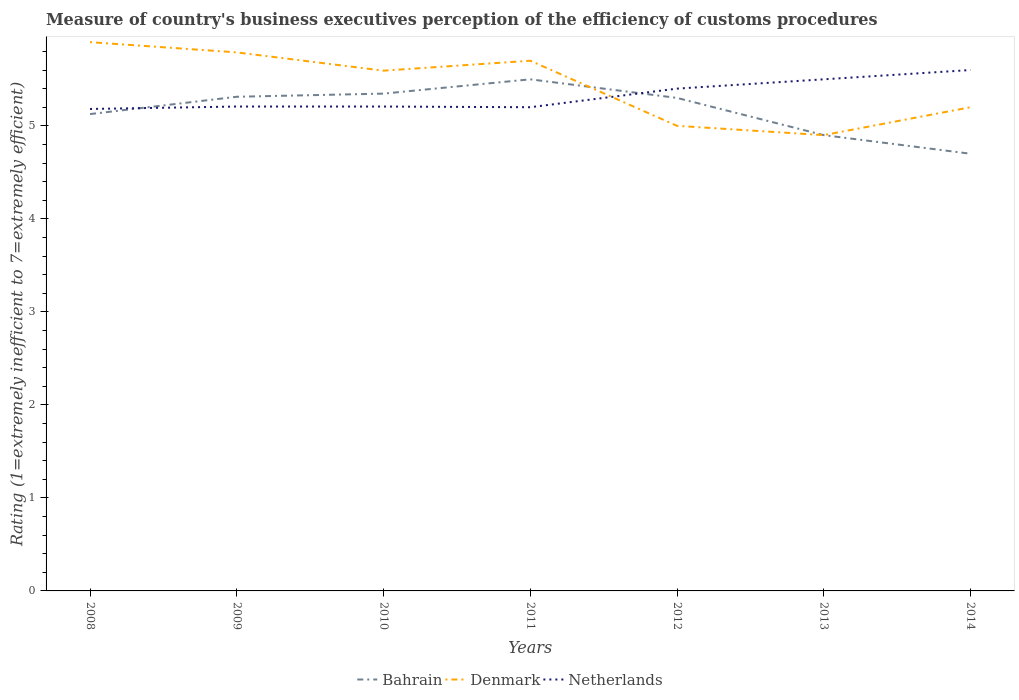How many different coloured lines are there?
Give a very brief answer. 3. Across all years, what is the maximum rating of the efficiency of customs procedure in Bahrain?
Offer a very short reply. 4.7. What is the total rating of the efficiency of customs procedure in Denmark in the graph?
Make the answer very short. 0.5. What is the difference between the highest and the second highest rating of the efficiency of customs procedure in Bahrain?
Keep it short and to the point. 0.8. What is the difference between the highest and the lowest rating of the efficiency of customs procedure in Denmark?
Your answer should be very brief. 4. Is the rating of the efficiency of customs procedure in Bahrain strictly greater than the rating of the efficiency of customs procedure in Netherlands over the years?
Your response must be concise. No. How many lines are there?
Provide a succinct answer. 3. How many years are there in the graph?
Provide a succinct answer. 7. What is the difference between two consecutive major ticks on the Y-axis?
Your answer should be very brief. 1. Does the graph contain any zero values?
Provide a short and direct response. No. Does the graph contain grids?
Make the answer very short. No. How many legend labels are there?
Offer a terse response. 3. What is the title of the graph?
Make the answer very short. Measure of country's business executives perception of the efficiency of customs procedures. Does "Hong Kong" appear as one of the legend labels in the graph?
Make the answer very short. No. What is the label or title of the Y-axis?
Keep it short and to the point. Rating (1=extremely inefficient to 7=extremely efficient). What is the Rating (1=extremely inefficient to 7=extremely efficient) of Bahrain in 2008?
Ensure brevity in your answer.  5.13. What is the Rating (1=extremely inefficient to 7=extremely efficient) in Denmark in 2008?
Make the answer very short. 5.9. What is the Rating (1=extremely inefficient to 7=extremely efficient) in Netherlands in 2008?
Offer a terse response. 5.18. What is the Rating (1=extremely inefficient to 7=extremely efficient) in Bahrain in 2009?
Offer a terse response. 5.31. What is the Rating (1=extremely inefficient to 7=extremely efficient) in Denmark in 2009?
Offer a very short reply. 5.79. What is the Rating (1=extremely inefficient to 7=extremely efficient) in Netherlands in 2009?
Provide a short and direct response. 5.21. What is the Rating (1=extremely inefficient to 7=extremely efficient) in Bahrain in 2010?
Offer a terse response. 5.35. What is the Rating (1=extremely inefficient to 7=extremely efficient) in Denmark in 2010?
Ensure brevity in your answer.  5.59. What is the Rating (1=extremely inefficient to 7=extremely efficient) of Netherlands in 2010?
Offer a very short reply. 5.21. What is the Rating (1=extremely inefficient to 7=extremely efficient) of Netherlands in 2011?
Give a very brief answer. 5.2. What is the Rating (1=extremely inefficient to 7=extremely efficient) of Denmark in 2012?
Provide a succinct answer. 5. What is the Rating (1=extremely inefficient to 7=extremely efficient) in Netherlands in 2012?
Offer a terse response. 5.4. What is the Rating (1=extremely inefficient to 7=extremely efficient) of Bahrain in 2013?
Make the answer very short. 4.9. What is the Rating (1=extremely inefficient to 7=extremely efficient) in Denmark in 2013?
Offer a terse response. 4.9. What is the Rating (1=extremely inefficient to 7=extremely efficient) in Denmark in 2014?
Your answer should be compact. 5.2. Across all years, what is the maximum Rating (1=extremely inefficient to 7=extremely efficient) of Denmark?
Your answer should be very brief. 5.9. Across all years, what is the minimum Rating (1=extremely inefficient to 7=extremely efficient) in Netherlands?
Ensure brevity in your answer.  5.18. What is the total Rating (1=extremely inefficient to 7=extremely efficient) of Bahrain in the graph?
Make the answer very short. 36.19. What is the total Rating (1=extremely inefficient to 7=extremely efficient) in Denmark in the graph?
Keep it short and to the point. 38.08. What is the total Rating (1=extremely inefficient to 7=extremely efficient) in Netherlands in the graph?
Ensure brevity in your answer.  37.3. What is the difference between the Rating (1=extremely inefficient to 7=extremely efficient) in Bahrain in 2008 and that in 2009?
Offer a very short reply. -0.19. What is the difference between the Rating (1=extremely inefficient to 7=extremely efficient) in Denmark in 2008 and that in 2009?
Ensure brevity in your answer.  0.11. What is the difference between the Rating (1=extremely inefficient to 7=extremely efficient) in Netherlands in 2008 and that in 2009?
Ensure brevity in your answer.  -0.03. What is the difference between the Rating (1=extremely inefficient to 7=extremely efficient) of Bahrain in 2008 and that in 2010?
Provide a succinct answer. -0.22. What is the difference between the Rating (1=extremely inefficient to 7=extremely efficient) in Denmark in 2008 and that in 2010?
Offer a very short reply. 0.31. What is the difference between the Rating (1=extremely inefficient to 7=extremely efficient) of Netherlands in 2008 and that in 2010?
Offer a very short reply. -0.03. What is the difference between the Rating (1=extremely inefficient to 7=extremely efficient) of Bahrain in 2008 and that in 2011?
Provide a short and direct response. -0.37. What is the difference between the Rating (1=extremely inefficient to 7=extremely efficient) in Denmark in 2008 and that in 2011?
Your response must be concise. 0.2. What is the difference between the Rating (1=extremely inefficient to 7=extremely efficient) of Netherlands in 2008 and that in 2011?
Keep it short and to the point. -0.02. What is the difference between the Rating (1=extremely inefficient to 7=extremely efficient) in Bahrain in 2008 and that in 2012?
Offer a very short reply. -0.17. What is the difference between the Rating (1=extremely inefficient to 7=extremely efficient) of Denmark in 2008 and that in 2012?
Your answer should be very brief. 0.9. What is the difference between the Rating (1=extremely inefficient to 7=extremely efficient) of Netherlands in 2008 and that in 2012?
Provide a succinct answer. -0.22. What is the difference between the Rating (1=extremely inefficient to 7=extremely efficient) of Bahrain in 2008 and that in 2013?
Your answer should be compact. 0.23. What is the difference between the Rating (1=extremely inefficient to 7=extremely efficient) of Denmark in 2008 and that in 2013?
Offer a terse response. 1. What is the difference between the Rating (1=extremely inefficient to 7=extremely efficient) of Netherlands in 2008 and that in 2013?
Offer a terse response. -0.32. What is the difference between the Rating (1=extremely inefficient to 7=extremely efficient) in Bahrain in 2008 and that in 2014?
Your answer should be very brief. 0.43. What is the difference between the Rating (1=extremely inefficient to 7=extremely efficient) of Denmark in 2008 and that in 2014?
Offer a terse response. 0.7. What is the difference between the Rating (1=extremely inefficient to 7=extremely efficient) in Netherlands in 2008 and that in 2014?
Offer a very short reply. -0.42. What is the difference between the Rating (1=extremely inefficient to 7=extremely efficient) in Bahrain in 2009 and that in 2010?
Make the answer very short. -0.03. What is the difference between the Rating (1=extremely inefficient to 7=extremely efficient) in Denmark in 2009 and that in 2010?
Your answer should be very brief. 0.2. What is the difference between the Rating (1=extremely inefficient to 7=extremely efficient) in Bahrain in 2009 and that in 2011?
Your response must be concise. -0.19. What is the difference between the Rating (1=extremely inefficient to 7=extremely efficient) of Denmark in 2009 and that in 2011?
Make the answer very short. 0.09. What is the difference between the Rating (1=extremely inefficient to 7=extremely efficient) of Netherlands in 2009 and that in 2011?
Your answer should be very brief. 0.01. What is the difference between the Rating (1=extremely inefficient to 7=extremely efficient) in Bahrain in 2009 and that in 2012?
Your answer should be very brief. 0.01. What is the difference between the Rating (1=extremely inefficient to 7=extremely efficient) of Denmark in 2009 and that in 2012?
Give a very brief answer. 0.79. What is the difference between the Rating (1=extremely inefficient to 7=extremely efficient) of Netherlands in 2009 and that in 2012?
Your answer should be compact. -0.19. What is the difference between the Rating (1=extremely inefficient to 7=extremely efficient) in Bahrain in 2009 and that in 2013?
Provide a succinct answer. 0.41. What is the difference between the Rating (1=extremely inefficient to 7=extremely efficient) of Denmark in 2009 and that in 2013?
Ensure brevity in your answer.  0.89. What is the difference between the Rating (1=extremely inefficient to 7=extremely efficient) in Netherlands in 2009 and that in 2013?
Your answer should be compact. -0.29. What is the difference between the Rating (1=extremely inefficient to 7=extremely efficient) in Bahrain in 2009 and that in 2014?
Your response must be concise. 0.61. What is the difference between the Rating (1=extremely inefficient to 7=extremely efficient) in Denmark in 2009 and that in 2014?
Keep it short and to the point. 0.59. What is the difference between the Rating (1=extremely inefficient to 7=extremely efficient) in Netherlands in 2009 and that in 2014?
Give a very brief answer. -0.39. What is the difference between the Rating (1=extremely inefficient to 7=extremely efficient) in Bahrain in 2010 and that in 2011?
Give a very brief answer. -0.15. What is the difference between the Rating (1=extremely inefficient to 7=extremely efficient) in Denmark in 2010 and that in 2011?
Offer a terse response. -0.11. What is the difference between the Rating (1=extremely inefficient to 7=extremely efficient) of Netherlands in 2010 and that in 2011?
Offer a very short reply. 0.01. What is the difference between the Rating (1=extremely inefficient to 7=extremely efficient) in Bahrain in 2010 and that in 2012?
Your answer should be compact. 0.05. What is the difference between the Rating (1=extremely inefficient to 7=extremely efficient) in Denmark in 2010 and that in 2012?
Ensure brevity in your answer.  0.59. What is the difference between the Rating (1=extremely inefficient to 7=extremely efficient) of Netherlands in 2010 and that in 2012?
Make the answer very short. -0.19. What is the difference between the Rating (1=extremely inefficient to 7=extremely efficient) of Bahrain in 2010 and that in 2013?
Make the answer very short. 0.45. What is the difference between the Rating (1=extremely inefficient to 7=extremely efficient) of Denmark in 2010 and that in 2013?
Offer a terse response. 0.69. What is the difference between the Rating (1=extremely inefficient to 7=extremely efficient) in Netherlands in 2010 and that in 2013?
Offer a very short reply. -0.29. What is the difference between the Rating (1=extremely inefficient to 7=extremely efficient) of Bahrain in 2010 and that in 2014?
Offer a very short reply. 0.65. What is the difference between the Rating (1=extremely inefficient to 7=extremely efficient) in Denmark in 2010 and that in 2014?
Provide a short and direct response. 0.39. What is the difference between the Rating (1=extremely inefficient to 7=extremely efficient) in Netherlands in 2010 and that in 2014?
Your answer should be very brief. -0.39. What is the difference between the Rating (1=extremely inefficient to 7=extremely efficient) in Bahrain in 2011 and that in 2012?
Offer a very short reply. 0.2. What is the difference between the Rating (1=extremely inefficient to 7=extremely efficient) of Denmark in 2011 and that in 2012?
Provide a short and direct response. 0.7. What is the difference between the Rating (1=extremely inefficient to 7=extremely efficient) in Denmark in 2011 and that in 2013?
Offer a terse response. 0.8. What is the difference between the Rating (1=extremely inefficient to 7=extremely efficient) in Netherlands in 2011 and that in 2013?
Your answer should be very brief. -0.3. What is the difference between the Rating (1=extremely inefficient to 7=extremely efficient) in Netherlands in 2011 and that in 2014?
Offer a very short reply. -0.4. What is the difference between the Rating (1=extremely inefficient to 7=extremely efficient) in Denmark in 2012 and that in 2013?
Your answer should be compact. 0.1. What is the difference between the Rating (1=extremely inefficient to 7=extremely efficient) of Netherlands in 2012 and that in 2013?
Ensure brevity in your answer.  -0.1. What is the difference between the Rating (1=extremely inefficient to 7=extremely efficient) of Bahrain in 2012 and that in 2014?
Offer a very short reply. 0.6. What is the difference between the Rating (1=extremely inefficient to 7=extremely efficient) of Bahrain in 2008 and the Rating (1=extremely inefficient to 7=extremely efficient) of Denmark in 2009?
Offer a terse response. -0.66. What is the difference between the Rating (1=extremely inefficient to 7=extremely efficient) in Bahrain in 2008 and the Rating (1=extremely inefficient to 7=extremely efficient) in Netherlands in 2009?
Make the answer very short. -0.08. What is the difference between the Rating (1=extremely inefficient to 7=extremely efficient) of Denmark in 2008 and the Rating (1=extremely inefficient to 7=extremely efficient) of Netherlands in 2009?
Provide a short and direct response. 0.69. What is the difference between the Rating (1=extremely inefficient to 7=extremely efficient) of Bahrain in 2008 and the Rating (1=extremely inefficient to 7=extremely efficient) of Denmark in 2010?
Ensure brevity in your answer.  -0.47. What is the difference between the Rating (1=extremely inefficient to 7=extremely efficient) of Bahrain in 2008 and the Rating (1=extremely inefficient to 7=extremely efficient) of Netherlands in 2010?
Provide a short and direct response. -0.08. What is the difference between the Rating (1=extremely inefficient to 7=extremely efficient) in Denmark in 2008 and the Rating (1=extremely inefficient to 7=extremely efficient) in Netherlands in 2010?
Offer a very short reply. 0.69. What is the difference between the Rating (1=extremely inefficient to 7=extremely efficient) of Bahrain in 2008 and the Rating (1=extremely inefficient to 7=extremely efficient) of Denmark in 2011?
Provide a succinct answer. -0.57. What is the difference between the Rating (1=extremely inefficient to 7=extremely efficient) of Bahrain in 2008 and the Rating (1=extremely inefficient to 7=extremely efficient) of Netherlands in 2011?
Provide a succinct answer. -0.07. What is the difference between the Rating (1=extremely inefficient to 7=extremely efficient) in Denmark in 2008 and the Rating (1=extremely inefficient to 7=extremely efficient) in Netherlands in 2011?
Offer a terse response. 0.7. What is the difference between the Rating (1=extremely inefficient to 7=extremely efficient) of Bahrain in 2008 and the Rating (1=extremely inefficient to 7=extremely efficient) of Denmark in 2012?
Keep it short and to the point. 0.13. What is the difference between the Rating (1=extremely inefficient to 7=extremely efficient) in Bahrain in 2008 and the Rating (1=extremely inefficient to 7=extremely efficient) in Netherlands in 2012?
Make the answer very short. -0.27. What is the difference between the Rating (1=extremely inefficient to 7=extremely efficient) in Denmark in 2008 and the Rating (1=extremely inefficient to 7=extremely efficient) in Netherlands in 2012?
Give a very brief answer. 0.5. What is the difference between the Rating (1=extremely inefficient to 7=extremely efficient) of Bahrain in 2008 and the Rating (1=extremely inefficient to 7=extremely efficient) of Denmark in 2013?
Your response must be concise. 0.23. What is the difference between the Rating (1=extremely inefficient to 7=extremely efficient) of Bahrain in 2008 and the Rating (1=extremely inefficient to 7=extremely efficient) of Netherlands in 2013?
Offer a terse response. -0.37. What is the difference between the Rating (1=extremely inefficient to 7=extremely efficient) of Denmark in 2008 and the Rating (1=extremely inefficient to 7=extremely efficient) of Netherlands in 2013?
Your answer should be very brief. 0.4. What is the difference between the Rating (1=extremely inefficient to 7=extremely efficient) of Bahrain in 2008 and the Rating (1=extremely inefficient to 7=extremely efficient) of Denmark in 2014?
Provide a short and direct response. -0.07. What is the difference between the Rating (1=extremely inefficient to 7=extremely efficient) of Bahrain in 2008 and the Rating (1=extremely inefficient to 7=extremely efficient) of Netherlands in 2014?
Provide a short and direct response. -0.47. What is the difference between the Rating (1=extremely inefficient to 7=extremely efficient) of Denmark in 2008 and the Rating (1=extremely inefficient to 7=extremely efficient) of Netherlands in 2014?
Your answer should be very brief. 0.3. What is the difference between the Rating (1=extremely inefficient to 7=extremely efficient) of Bahrain in 2009 and the Rating (1=extremely inefficient to 7=extremely efficient) of Denmark in 2010?
Provide a succinct answer. -0.28. What is the difference between the Rating (1=extremely inefficient to 7=extremely efficient) in Bahrain in 2009 and the Rating (1=extremely inefficient to 7=extremely efficient) in Netherlands in 2010?
Keep it short and to the point. 0.11. What is the difference between the Rating (1=extremely inefficient to 7=extremely efficient) in Denmark in 2009 and the Rating (1=extremely inefficient to 7=extremely efficient) in Netherlands in 2010?
Your answer should be compact. 0.58. What is the difference between the Rating (1=extremely inefficient to 7=extremely efficient) of Bahrain in 2009 and the Rating (1=extremely inefficient to 7=extremely efficient) of Denmark in 2011?
Offer a terse response. -0.39. What is the difference between the Rating (1=extremely inefficient to 7=extremely efficient) of Bahrain in 2009 and the Rating (1=extremely inefficient to 7=extremely efficient) of Netherlands in 2011?
Your answer should be compact. 0.11. What is the difference between the Rating (1=extremely inefficient to 7=extremely efficient) in Denmark in 2009 and the Rating (1=extremely inefficient to 7=extremely efficient) in Netherlands in 2011?
Provide a short and direct response. 0.59. What is the difference between the Rating (1=extremely inefficient to 7=extremely efficient) in Bahrain in 2009 and the Rating (1=extremely inefficient to 7=extremely efficient) in Denmark in 2012?
Make the answer very short. 0.31. What is the difference between the Rating (1=extremely inefficient to 7=extremely efficient) in Bahrain in 2009 and the Rating (1=extremely inefficient to 7=extremely efficient) in Netherlands in 2012?
Offer a very short reply. -0.09. What is the difference between the Rating (1=extremely inefficient to 7=extremely efficient) of Denmark in 2009 and the Rating (1=extremely inefficient to 7=extremely efficient) of Netherlands in 2012?
Your answer should be very brief. 0.39. What is the difference between the Rating (1=extremely inefficient to 7=extremely efficient) in Bahrain in 2009 and the Rating (1=extremely inefficient to 7=extremely efficient) in Denmark in 2013?
Your answer should be compact. 0.41. What is the difference between the Rating (1=extremely inefficient to 7=extremely efficient) of Bahrain in 2009 and the Rating (1=extremely inefficient to 7=extremely efficient) of Netherlands in 2013?
Keep it short and to the point. -0.19. What is the difference between the Rating (1=extremely inefficient to 7=extremely efficient) of Denmark in 2009 and the Rating (1=extremely inefficient to 7=extremely efficient) of Netherlands in 2013?
Offer a terse response. 0.29. What is the difference between the Rating (1=extremely inefficient to 7=extremely efficient) of Bahrain in 2009 and the Rating (1=extremely inefficient to 7=extremely efficient) of Denmark in 2014?
Provide a short and direct response. 0.11. What is the difference between the Rating (1=extremely inefficient to 7=extremely efficient) of Bahrain in 2009 and the Rating (1=extremely inefficient to 7=extremely efficient) of Netherlands in 2014?
Your response must be concise. -0.29. What is the difference between the Rating (1=extremely inefficient to 7=extremely efficient) in Denmark in 2009 and the Rating (1=extremely inefficient to 7=extremely efficient) in Netherlands in 2014?
Make the answer very short. 0.19. What is the difference between the Rating (1=extremely inefficient to 7=extremely efficient) of Bahrain in 2010 and the Rating (1=extremely inefficient to 7=extremely efficient) of Denmark in 2011?
Give a very brief answer. -0.35. What is the difference between the Rating (1=extremely inefficient to 7=extremely efficient) in Bahrain in 2010 and the Rating (1=extremely inefficient to 7=extremely efficient) in Netherlands in 2011?
Your response must be concise. 0.15. What is the difference between the Rating (1=extremely inefficient to 7=extremely efficient) of Denmark in 2010 and the Rating (1=extremely inefficient to 7=extremely efficient) of Netherlands in 2011?
Give a very brief answer. 0.39. What is the difference between the Rating (1=extremely inefficient to 7=extremely efficient) of Bahrain in 2010 and the Rating (1=extremely inefficient to 7=extremely efficient) of Denmark in 2012?
Ensure brevity in your answer.  0.35. What is the difference between the Rating (1=extremely inefficient to 7=extremely efficient) of Bahrain in 2010 and the Rating (1=extremely inefficient to 7=extremely efficient) of Netherlands in 2012?
Your response must be concise. -0.05. What is the difference between the Rating (1=extremely inefficient to 7=extremely efficient) in Denmark in 2010 and the Rating (1=extremely inefficient to 7=extremely efficient) in Netherlands in 2012?
Provide a succinct answer. 0.19. What is the difference between the Rating (1=extremely inefficient to 7=extremely efficient) of Bahrain in 2010 and the Rating (1=extremely inefficient to 7=extremely efficient) of Denmark in 2013?
Your answer should be very brief. 0.45. What is the difference between the Rating (1=extremely inefficient to 7=extremely efficient) in Bahrain in 2010 and the Rating (1=extremely inefficient to 7=extremely efficient) in Netherlands in 2013?
Offer a very short reply. -0.15. What is the difference between the Rating (1=extremely inefficient to 7=extremely efficient) of Denmark in 2010 and the Rating (1=extremely inefficient to 7=extremely efficient) of Netherlands in 2013?
Keep it short and to the point. 0.09. What is the difference between the Rating (1=extremely inefficient to 7=extremely efficient) in Bahrain in 2010 and the Rating (1=extremely inefficient to 7=extremely efficient) in Denmark in 2014?
Your response must be concise. 0.15. What is the difference between the Rating (1=extremely inefficient to 7=extremely efficient) of Bahrain in 2010 and the Rating (1=extremely inefficient to 7=extremely efficient) of Netherlands in 2014?
Provide a succinct answer. -0.25. What is the difference between the Rating (1=extremely inefficient to 7=extremely efficient) of Denmark in 2010 and the Rating (1=extremely inefficient to 7=extremely efficient) of Netherlands in 2014?
Your response must be concise. -0.01. What is the difference between the Rating (1=extremely inefficient to 7=extremely efficient) in Denmark in 2011 and the Rating (1=extremely inefficient to 7=extremely efficient) in Netherlands in 2012?
Offer a terse response. 0.3. What is the difference between the Rating (1=extremely inefficient to 7=extremely efficient) of Bahrain in 2011 and the Rating (1=extremely inefficient to 7=extremely efficient) of Denmark in 2013?
Make the answer very short. 0.6. What is the difference between the Rating (1=extremely inefficient to 7=extremely efficient) in Bahrain in 2011 and the Rating (1=extremely inefficient to 7=extremely efficient) in Denmark in 2014?
Ensure brevity in your answer.  0.3. What is the difference between the Rating (1=extremely inefficient to 7=extremely efficient) in Denmark in 2011 and the Rating (1=extremely inefficient to 7=extremely efficient) in Netherlands in 2014?
Your answer should be compact. 0.1. What is the difference between the Rating (1=extremely inefficient to 7=extremely efficient) in Denmark in 2012 and the Rating (1=extremely inefficient to 7=extremely efficient) in Netherlands in 2013?
Provide a succinct answer. -0.5. What is the difference between the Rating (1=extremely inefficient to 7=extremely efficient) in Bahrain in 2012 and the Rating (1=extremely inefficient to 7=extremely efficient) in Netherlands in 2014?
Provide a short and direct response. -0.3. What is the difference between the Rating (1=extremely inefficient to 7=extremely efficient) in Bahrain in 2013 and the Rating (1=extremely inefficient to 7=extremely efficient) in Denmark in 2014?
Provide a short and direct response. -0.3. What is the difference between the Rating (1=extremely inefficient to 7=extremely efficient) in Denmark in 2013 and the Rating (1=extremely inefficient to 7=extremely efficient) in Netherlands in 2014?
Provide a short and direct response. -0.7. What is the average Rating (1=extremely inefficient to 7=extremely efficient) of Bahrain per year?
Keep it short and to the point. 5.17. What is the average Rating (1=extremely inefficient to 7=extremely efficient) of Denmark per year?
Give a very brief answer. 5.44. What is the average Rating (1=extremely inefficient to 7=extremely efficient) in Netherlands per year?
Your answer should be very brief. 5.33. In the year 2008, what is the difference between the Rating (1=extremely inefficient to 7=extremely efficient) in Bahrain and Rating (1=extremely inefficient to 7=extremely efficient) in Denmark?
Ensure brevity in your answer.  -0.77. In the year 2008, what is the difference between the Rating (1=extremely inefficient to 7=extremely efficient) of Bahrain and Rating (1=extremely inefficient to 7=extremely efficient) of Netherlands?
Provide a short and direct response. -0.06. In the year 2008, what is the difference between the Rating (1=extremely inefficient to 7=extremely efficient) of Denmark and Rating (1=extremely inefficient to 7=extremely efficient) of Netherlands?
Keep it short and to the point. 0.72. In the year 2009, what is the difference between the Rating (1=extremely inefficient to 7=extremely efficient) of Bahrain and Rating (1=extremely inefficient to 7=extremely efficient) of Denmark?
Provide a succinct answer. -0.48. In the year 2009, what is the difference between the Rating (1=extremely inefficient to 7=extremely efficient) in Bahrain and Rating (1=extremely inefficient to 7=extremely efficient) in Netherlands?
Your response must be concise. 0.1. In the year 2009, what is the difference between the Rating (1=extremely inefficient to 7=extremely efficient) of Denmark and Rating (1=extremely inefficient to 7=extremely efficient) of Netherlands?
Your answer should be very brief. 0.58. In the year 2010, what is the difference between the Rating (1=extremely inefficient to 7=extremely efficient) in Bahrain and Rating (1=extremely inefficient to 7=extremely efficient) in Denmark?
Offer a terse response. -0.25. In the year 2010, what is the difference between the Rating (1=extremely inefficient to 7=extremely efficient) of Bahrain and Rating (1=extremely inefficient to 7=extremely efficient) of Netherlands?
Keep it short and to the point. 0.14. In the year 2010, what is the difference between the Rating (1=extremely inefficient to 7=extremely efficient) in Denmark and Rating (1=extremely inefficient to 7=extremely efficient) in Netherlands?
Ensure brevity in your answer.  0.39. In the year 2011, what is the difference between the Rating (1=extremely inefficient to 7=extremely efficient) in Bahrain and Rating (1=extremely inefficient to 7=extremely efficient) in Denmark?
Provide a succinct answer. -0.2. In the year 2013, what is the difference between the Rating (1=extremely inefficient to 7=extremely efficient) in Bahrain and Rating (1=extremely inefficient to 7=extremely efficient) in Netherlands?
Offer a very short reply. -0.6. In the year 2014, what is the difference between the Rating (1=extremely inefficient to 7=extremely efficient) in Bahrain and Rating (1=extremely inefficient to 7=extremely efficient) in Denmark?
Your answer should be compact. -0.5. What is the ratio of the Rating (1=extremely inefficient to 7=extremely efficient) in Bahrain in 2008 to that in 2010?
Your answer should be very brief. 0.96. What is the ratio of the Rating (1=extremely inefficient to 7=extremely efficient) of Denmark in 2008 to that in 2010?
Your response must be concise. 1.05. What is the ratio of the Rating (1=extremely inefficient to 7=extremely efficient) of Netherlands in 2008 to that in 2010?
Make the answer very short. 0.99. What is the ratio of the Rating (1=extremely inefficient to 7=extremely efficient) in Bahrain in 2008 to that in 2011?
Your answer should be very brief. 0.93. What is the ratio of the Rating (1=extremely inefficient to 7=extremely efficient) of Denmark in 2008 to that in 2011?
Your answer should be very brief. 1.03. What is the ratio of the Rating (1=extremely inefficient to 7=extremely efficient) of Netherlands in 2008 to that in 2011?
Provide a succinct answer. 1. What is the ratio of the Rating (1=extremely inefficient to 7=extremely efficient) of Bahrain in 2008 to that in 2012?
Provide a short and direct response. 0.97. What is the ratio of the Rating (1=extremely inefficient to 7=extremely efficient) of Denmark in 2008 to that in 2012?
Keep it short and to the point. 1.18. What is the ratio of the Rating (1=extremely inefficient to 7=extremely efficient) of Netherlands in 2008 to that in 2012?
Your answer should be compact. 0.96. What is the ratio of the Rating (1=extremely inefficient to 7=extremely efficient) of Bahrain in 2008 to that in 2013?
Provide a short and direct response. 1.05. What is the ratio of the Rating (1=extremely inefficient to 7=extremely efficient) in Denmark in 2008 to that in 2013?
Offer a very short reply. 1.2. What is the ratio of the Rating (1=extremely inefficient to 7=extremely efficient) in Netherlands in 2008 to that in 2013?
Ensure brevity in your answer.  0.94. What is the ratio of the Rating (1=extremely inefficient to 7=extremely efficient) of Bahrain in 2008 to that in 2014?
Your response must be concise. 1.09. What is the ratio of the Rating (1=extremely inefficient to 7=extremely efficient) in Denmark in 2008 to that in 2014?
Keep it short and to the point. 1.13. What is the ratio of the Rating (1=extremely inefficient to 7=extremely efficient) in Netherlands in 2008 to that in 2014?
Provide a short and direct response. 0.93. What is the ratio of the Rating (1=extremely inefficient to 7=extremely efficient) in Denmark in 2009 to that in 2010?
Give a very brief answer. 1.04. What is the ratio of the Rating (1=extremely inefficient to 7=extremely efficient) of Netherlands in 2009 to that in 2010?
Provide a short and direct response. 1. What is the ratio of the Rating (1=extremely inefficient to 7=extremely efficient) in Bahrain in 2009 to that in 2011?
Keep it short and to the point. 0.97. What is the ratio of the Rating (1=extremely inefficient to 7=extremely efficient) in Denmark in 2009 to that in 2011?
Offer a terse response. 1.02. What is the ratio of the Rating (1=extremely inefficient to 7=extremely efficient) in Netherlands in 2009 to that in 2011?
Provide a succinct answer. 1. What is the ratio of the Rating (1=extremely inefficient to 7=extremely efficient) in Denmark in 2009 to that in 2012?
Give a very brief answer. 1.16. What is the ratio of the Rating (1=extremely inefficient to 7=extremely efficient) in Netherlands in 2009 to that in 2012?
Your response must be concise. 0.96. What is the ratio of the Rating (1=extremely inefficient to 7=extremely efficient) in Bahrain in 2009 to that in 2013?
Your answer should be compact. 1.08. What is the ratio of the Rating (1=extremely inefficient to 7=extremely efficient) of Denmark in 2009 to that in 2013?
Provide a succinct answer. 1.18. What is the ratio of the Rating (1=extremely inefficient to 7=extremely efficient) of Netherlands in 2009 to that in 2013?
Offer a terse response. 0.95. What is the ratio of the Rating (1=extremely inefficient to 7=extremely efficient) in Bahrain in 2009 to that in 2014?
Your response must be concise. 1.13. What is the ratio of the Rating (1=extremely inefficient to 7=extremely efficient) in Denmark in 2009 to that in 2014?
Provide a short and direct response. 1.11. What is the ratio of the Rating (1=extremely inefficient to 7=extremely efficient) of Netherlands in 2009 to that in 2014?
Ensure brevity in your answer.  0.93. What is the ratio of the Rating (1=extremely inefficient to 7=extremely efficient) in Bahrain in 2010 to that in 2011?
Your response must be concise. 0.97. What is the ratio of the Rating (1=extremely inefficient to 7=extremely efficient) in Denmark in 2010 to that in 2011?
Ensure brevity in your answer.  0.98. What is the ratio of the Rating (1=extremely inefficient to 7=extremely efficient) in Netherlands in 2010 to that in 2011?
Make the answer very short. 1. What is the ratio of the Rating (1=extremely inefficient to 7=extremely efficient) of Bahrain in 2010 to that in 2012?
Give a very brief answer. 1.01. What is the ratio of the Rating (1=extremely inefficient to 7=extremely efficient) of Denmark in 2010 to that in 2012?
Offer a terse response. 1.12. What is the ratio of the Rating (1=extremely inefficient to 7=extremely efficient) of Bahrain in 2010 to that in 2013?
Keep it short and to the point. 1.09. What is the ratio of the Rating (1=extremely inefficient to 7=extremely efficient) in Denmark in 2010 to that in 2013?
Provide a short and direct response. 1.14. What is the ratio of the Rating (1=extremely inefficient to 7=extremely efficient) in Netherlands in 2010 to that in 2013?
Your answer should be very brief. 0.95. What is the ratio of the Rating (1=extremely inefficient to 7=extremely efficient) in Bahrain in 2010 to that in 2014?
Your answer should be compact. 1.14. What is the ratio of the Rating (1=extremely inefficient to 7=extremely efficient) of Denmark in 2010 to that in 2014?
Your response must be concise. 1.08. What is the ratio of the Rating (1=extremely inefficient to 7=extremely efficient) of Netherlands in 2010 to that in 2014?
Offer a very short reply. 0.93. What is the ratio of the Rating (1=extremely inefficient to 7=extremely efficient) of Bahrain in 2011 to that in 2012?
Provide a succinct answer. 1.04. What is the ratio of the Rating (1=extremely inefficient to 7=extremely efficient) of Denmark in 2011 to that in 2012?
Offer a terse response. 1.14. What is the ratio of the Rating (1=extremely inefficient to 7=extremely efficient) of Netherlands in 2011 to that in 2012?
Make the answer very short. 0.96. What is the ratio of the Rating (1=extremely inefficient to 7=extremely efficient) of Bahrain in 2011 to that in 2013?
Ensure brevity in your answer.  1.12. What is the ratio of the Rating (1=extremely inefficient to 7=extremely efficient) of Denmark in 2011 to that in 2013?
Your answer should be very brief. 1.16. What is the ratio of the Rating (1=extremely inefficient to 7=extremely efficient) in Netherlands in 2011 to that in 2013?
Give a very brief answer. 0.95. What is the ratio of the Rating (1=extremely inefficient to 7=extremely efficient) in Bahrain in 2011 to that in 2014?
Make the answer very short. 1.17. What is the ratio of the Rating (1=extremely inefficient to 7=extremely efficient) of Denmark in 2011 to that in 2014?
Offer a very short reply. 1.1. What is the ratio of the Rating (1=extremely inefficient to 7=extremely efficient) in Netherlands in 2011 to that in 2014?
Give a very brief answer. 0.93. What is the ratio of the Rating (1=extremely inefficient to 7=extremely efficient) of Bahrain in 2012 to that in 2013?
Provide a short and direct response. 1.08. What is the ratio of the Rating (1=extremely inefficient to 7=extremely efficient) of Denmark in 2012 to that in 2013?
Provide a succinct answer. 1.02. What is the ratio of the Rating (1=extremely inefficient to 7=extremely efficient) of Netherlands in 2012 to that in 2013?
Provide a succinct answer. 0.98. What is the ratio of the Rating (1=extremely inefficient to 7=extremely efficient) in Bahrain in 2012 to that in 2014?
Your response must be concise. 1.13. What is the ratio of the Rating (1=extremely inefficient to 7=extremely efficient) in Denmark in 2012 to that in 2014?
Offer a very short reply. 0.96. What is the ratio of the Rating (1=extremely inefficient to 7=extremely efficient) in Netherlands in 2012 to that in 2014?
Make the answer very short. 0.96. What is the ratio of the Rating (1=extremely inefficient to 7=extremely efficient) in Bahrain in 2013 to that in 2014?
Provide a short and direct response. 1.04. What is the ratio of the Rating (1=extremely inefficient to 7=extremely efficient) in Denmark in 2013 to that in 2014?
Provide a short and direct response. 0.94. What is the ratio of the Rating (1=extremely inefficient to 7=extremely efficient) of Netherlands in 2013 to that in 2014?
Your answer should be compact. 0.98. What is the difference between the highest and the second highest Rating (1=extremely inefficient to 7=extremely efficient) in Bahrain?
Offer a terse response. 0.15. What is the difference between the highest and the second highest Rating (1=extremely inefficient to 7=extremely efficient) of Denmark?
Offer a very short reply. 0.11. What is the difference between the highest and the second highest Rating (1=extremely inefficient to 7=extremely efficient) of Netherlands?
Your response must be concise. 0.1. What is the difference between the highest and the lowest Rating (1=extremely inefficient to 7=extremely efficient) in Bahrain?
Your answer should be very brief. 0.8. What is the difference between the highest and the lowest Rating (1=extremely inefficient to 7=extremely efficient) in Netherlands?
Your answer should be very brief. 0.42. 